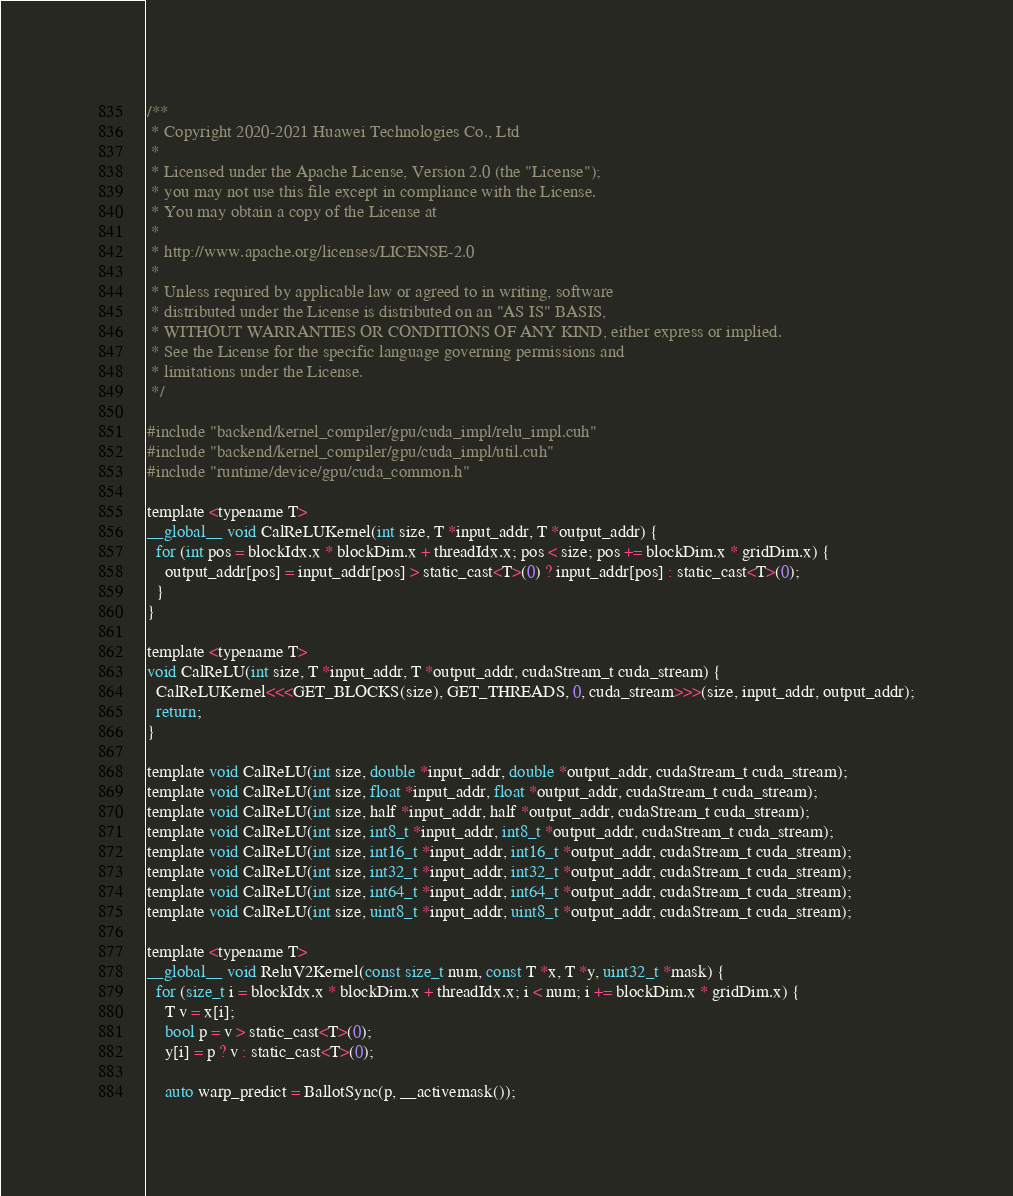<code> <loc_0><loc_0><loc_500><loc_500><_Cuda_>/**
 * Copyright 2020-2021 Huawei Technologies Co., Ltd
 *
 * Licensed under the Apache License, Version 2.0 (the "License");
 * you may not use this file except in compliance with the License.
 * You may obtain a copy of the License at
 *
 * http://www.apache.org/licenses/LICENSE-2.0
 *
 * Unless required by applicable law or agreed to in writing, software
 * distributed under the License is distributed on an "AS IS" BASIS,
 * WITHOUT WARRANTIES OR CONDITIONS OF ANY KIND, either express or implied.
 * See the License for the specific language governing permissions and
 * limitations under the License.
 */

#include "backend/kernel_compiler/gpu/cuda_impl/relu_impl.cuh"
#include "backend/kernel_compiler/gpu/cuda_impl/util.cuh"
#include "runtime/device/gpu/cuda_common.h"

template <typename T>
__global__ void CalReLUKernel(int size, T *input_addr, T *output_addr) {
  for (int pos = blockIdx.x * blockDim.x + threadIdx.x; pos < size; pos += blockDim.x * gridDim.x) {
    output_addr[pos] = input_addr[pos] > static_cast<T>(0) ? input_addr[pos] : static_cast<T>(0);
  }
}

template <typename T>
void CalReLU(int size, T *input_addr, T *output_addr, cudaStream_t cuda_stream) {
  CalReLUKernel<<<GET_BLOCKS(size), GET_THREADS, 0, cuda_stream>>>(size, input_addr, output_addr);
  return;
}

template void CalReLU(int size, double *input_addr, double *output_addr, cudaStream_t cuda_stream);
template void CalReLU(int size, float *input_addr, float *output_addr, cudaStream_t cuda_stream);
template void CalReLU(int size, half *input_addr, half *output_addr, cudaStream_t cuda_stream);
template void CalReLU(int size, int8_t *input_addr, int8_t *output_addr, cudaStream_t cuda_stream);
template void CalReLU(int size, int16_t *input_addr, int16_t *output_addr, cudaStream_t cuda_stream);
template void CalReLU(int size, int32_t *input_addr, int32_t *output_addr, cudaStream_t cuda_stream);
template void CalReLU(int size, int64_t *input_addr, int64_t *output_addr, cudaStream_t cuda_stream);
template void CalReLU(int size, uint8_t *input_addr, uint8_t *output_addr, cudaStream_t cuda_stream);

template <typename T>
__global__ void ReluV2Kernel(const size_t num, const T *x, T *y, uint32_t *mask) {
  for (size_t i = blockIdx.x * blockDim.x + threadIdx.x; i < num; i += blockDim.x * gridDim.x) {
    T v = x[i];
    bool p = v > static_cast<T>(0);
    y[i] = p ? v : static_cast<T>(0);

    auto warp_predict = BallotSync(p, __activemask());</code> 